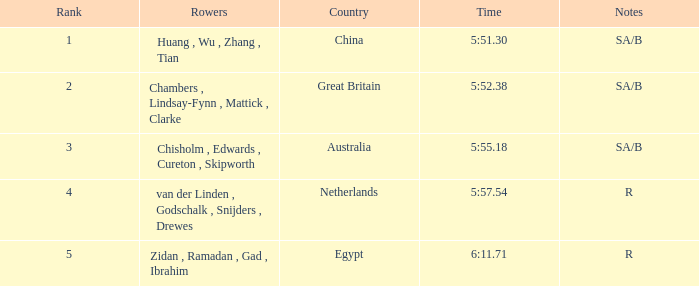Who were the oarsmen when notations were sa/b, with a time of 5:5 Huang , Wu , Zhang , Tian. 